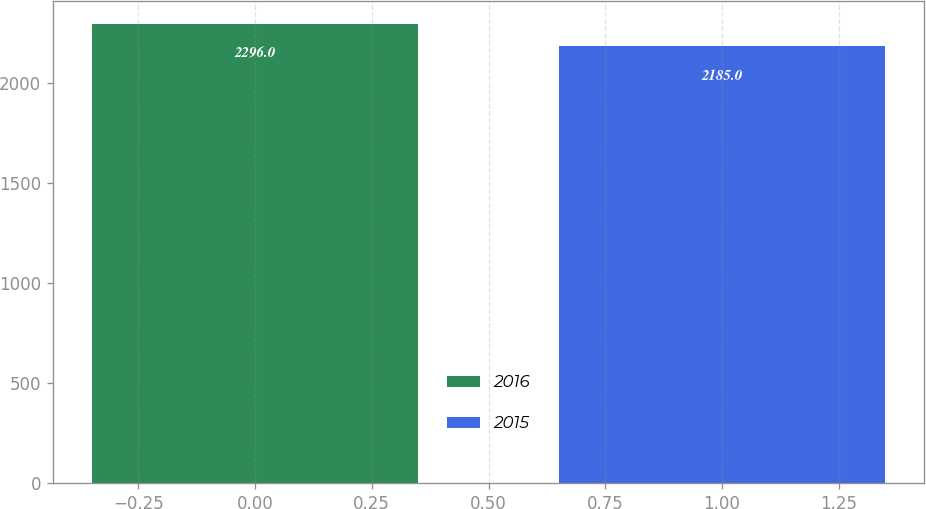Convert chart. <chart><loc_0><loc_0><loc_500><loc_500><bar_chart><fcel>2016<fcel>2015<nl><fcel>2296<fcel>2185<nl></chart> 